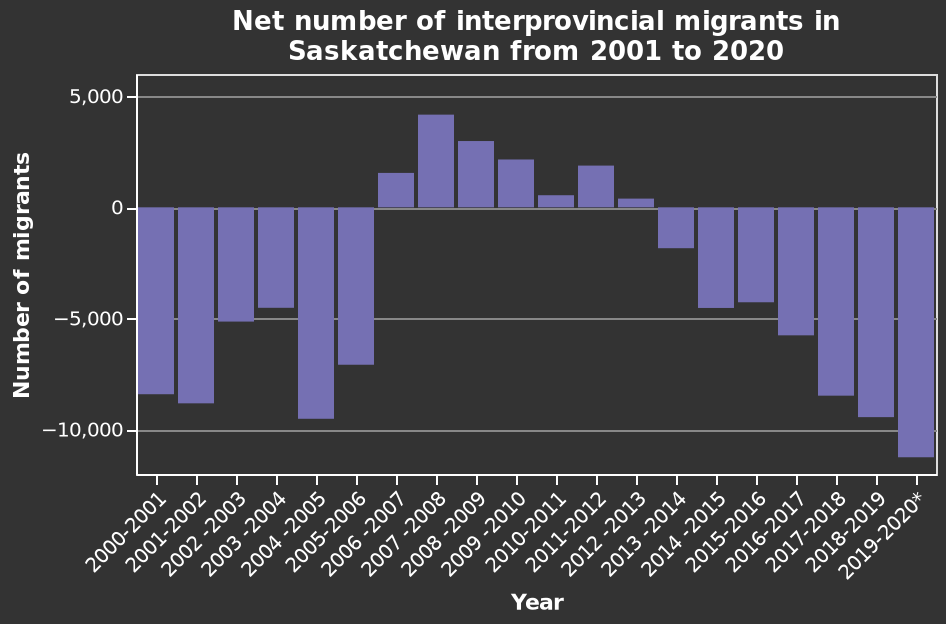<image>
Did the net number of interprovincial migrants increase at any point between 2000 and 2020?  Yes, the net number of interprovincial migrants did rise between 2007 and 2013. What was the trend in the net number of interprovincial migrants between 2000 and 2020?  The net number of interprovincial migrants fell dramatically during this period. What does the x-axis represent in the bar diagram?  The x-axis represents the years from 2000-2001 to 2019-2020. Did the net number of interprovincial migrants rise significantly during this period? No. The net number of interprovincial migrants fell dramatically during this period. 